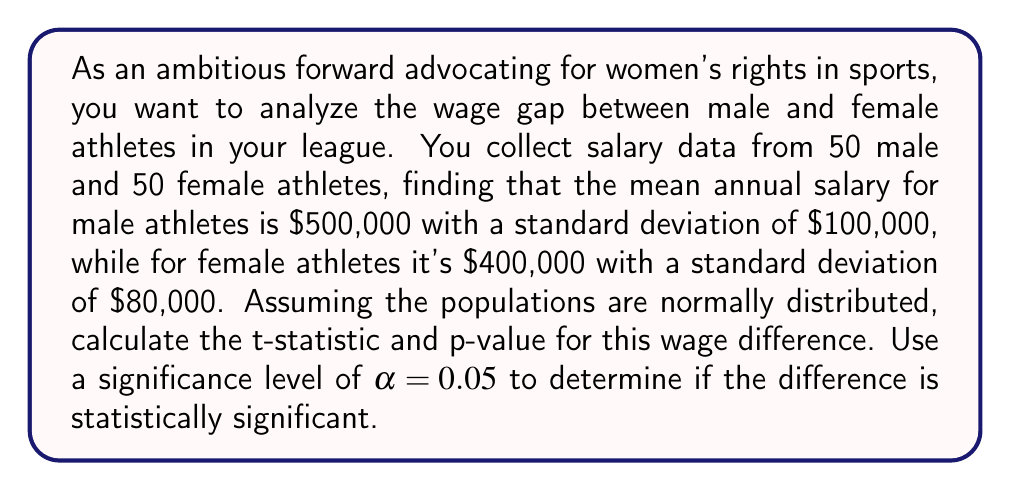Can you solve this math problem? To determine if the wage difference is statistically significant, we'll use a two-sample t-test for independent samples with unequal variances (Welch's t-test).

Step 1: Calculate the t-statistic
The formula for the t-statistic is:

$$ t = \frac{\bar{X}_1 - \bar{X}_2}{\sqrt{\frac{s_1^2}{n_1} + \frac{s_2^2}{n_2}}} $$

Where:
$\bar{X}_1$ = mean salary of male athletes = $500,000
$\bar{X}_2$ = mean salary of female athletes = $400,000
$s_1$ = standard deviation of male athletes' salaries = $100,000
$s_2$ = standard deviation of female athletes' salaries = $80,000
$n_1 = n_2$ = 50 (sample size for each group)

Plugging in the values:

$$ t = \frac{500,000 - 400,000}{\sqrt{\frac{100,000^2}{50} + \frac{80,000^2}{50}}} = \frac{100,000}{\sqrt{200,000,000 + 128,000,000}} = \frac{100,000}{\sqrt{328,000,000}} = \frac{100,000}{18,110.77} = 5.52 $$

Step 2: Calculate degrees of freedom
For Welch's t-test, we use the Welch–Satterthwaite equation to estimate the degrees of freedom:

$$ \nu \approx \frac{(\frac{s_1^2}{n_1} + \frac{s_2^2}{n_2})^2}{\frac{(s_1^2/n_1)^2}{n_1-1} + \frac{(s_2^2/n_2)^2}{n_2-1}} $$

Plugging in the values:

$$ \nu \approx \frac{(200,000,000 + 128,000,000)^2}{\frac{200,000,000^2}{49} + \frac{128,000,000^2}{49}} \approx 95.45 $$

We'll round down to 95 degrees of freedom.

Step 3: Determine the critical t-value
For a two-tailed test with α = 0.05 and 95 degrees of freedom, the critical t-value is approximately ±1.985.

Step 4: Calculate the p-value
Using a t-distribution calculator or table with 95 degrees of freedom, we find that the p-value for t = 5.52 is p < 0.0001.

Step 5: Interpret the results
Since |t| = 5.52 > 1.985 (critical t-value) and p < 0.0001 < 0.05 (α), we reject the null hypothesis.
Answer: The t-statistic is 5.52, and the p-value is < 0.0001. Since the p-value is less than the significance level of 0.05, we conclude that the wage difference between male and female athletes in the league is statistically significant. 